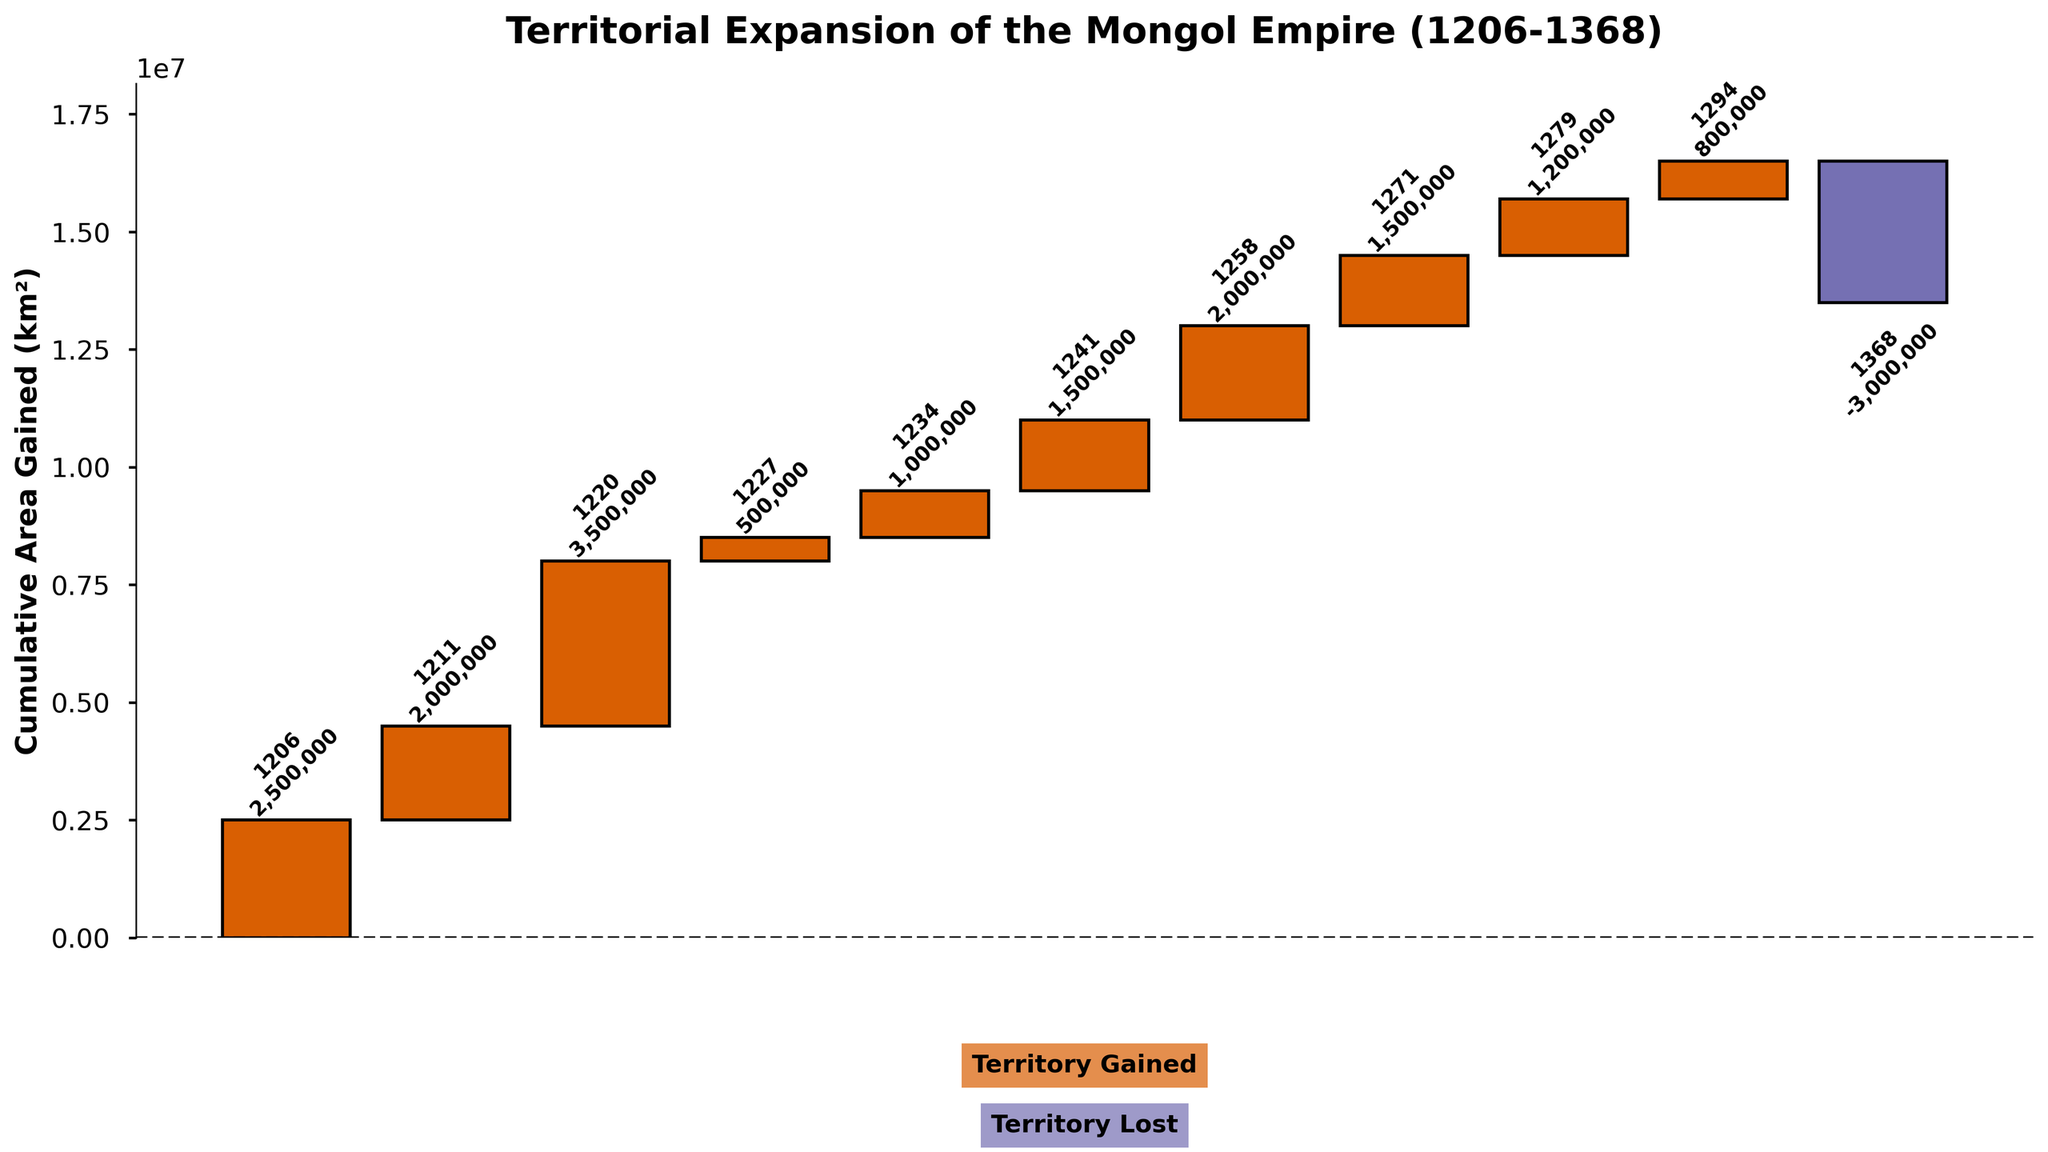How much cumulative area did the Mongol Empire gain by the mid-13th century? We look at the cumulative sums in the plot around the mid-13th century, particularly at 1258 when the Abbasid Caliphate was conquered, adding significant territory. By this time, the cumulative area sum is around 9,000,000 km²
Answer: 9,000,000 km² Which conquest after 1270 gained the most territory? Post-1270, the Territorial acquisitions are from Southern Song (Complete) in 1271, Tibet in 1279, and Southeast Asia in 1294. Comparing these, the Southern Song (Complete) conquest in 1271 gained the most territory with 1,500,000 km²
Answer: Southern Song (Complete) How many times did the Mongol Empire add territories greater than 1,000,000 km²? Identifying territories greater than 1,000,000 km² includes Jin Dynasty (2,000,000 km²), Khwarezmian Empire (3,500,000 km²), Southern Song (1,000,000 km²), Eastern Europe (1,500,000 km²), Abbasid Caliphate (2,000,000 km²), Southern Song (Complete) (1,500,000 km²), and Tibet (1,200,000 km²). So 7 times
Answer: 7 times What was the only negative data point, and when did it occur? The negative data point is evident by its distinctive color and indicating a decrease in territory. According to the text within the plot, the negative area occurred in 1368 with a value of -3,000,000 km²
Answer: 1368 What was the total area gained from the conquests of the Khwarezmian Empire and the Abbasid Caliphate combined? Summing the areas gained from the 1220 conquest of the Khwarezmian Empire (3,500,000 km²) and the 1258 conquest of the Abbasid Caliphate (2,000,000 km²), the combined total is 5,500,000 km²
Answer: 5,500,000 km² Between the conquerings of Jin Dynasty Territories and Eastern Europe, which added more to the Mongol Empire's territory? Jin Dynasty Territories were conquered in 1211, adding 2,000,000 km². Eastern Europe was conquered in 1241, adding 1,500,000 km². Thus, the Jin Dynasty conquest added more
Answer: Jin Dynasty Territories How does the cumulative area gained after the conquest of the Southern Song in 1234 compare to that after conquering Tibet in 1279? The plot shows the cumulative area for Southern Song (1234) as 8,000,000 km², and after Tibet (1279), it's 12,200,000 km². Thus, Tibet had a higher cumulative area
Answer: 12,200,000 km² 